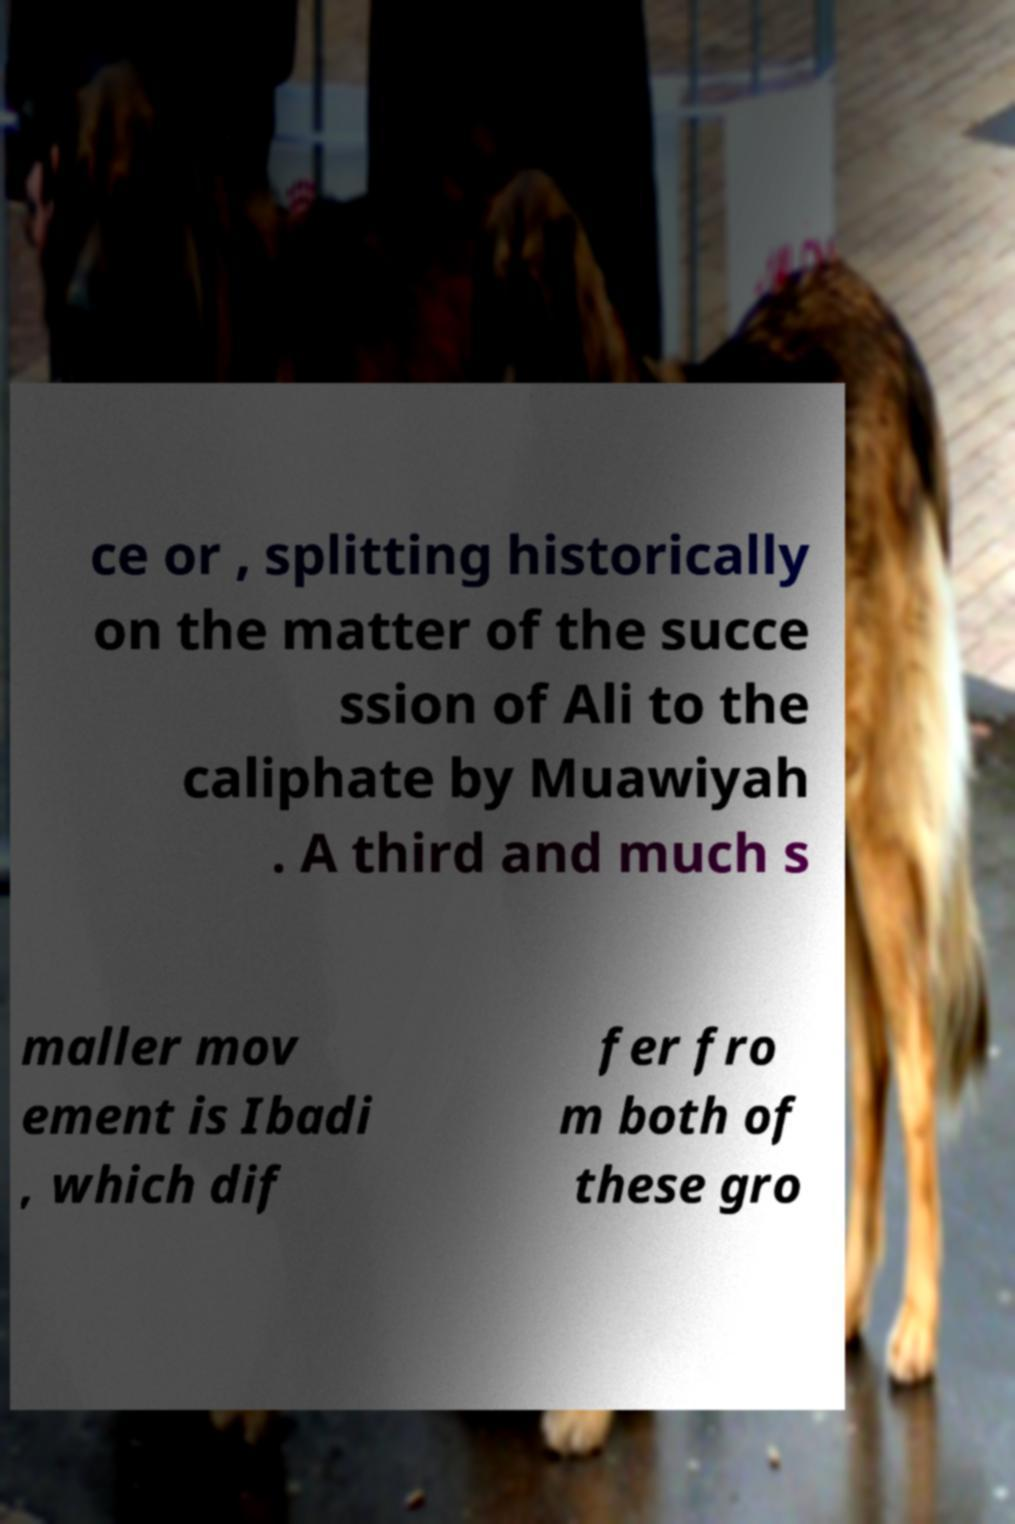There's text embedded in this image that I need extracted. Can you transcribe it verbatim? ce or , splitting historically on the matter of the succe ssion of Ali to the caliphate by Muawiyah . A third and much s maller mov ement is Ibadi , which dif fer fro m both of these gro 